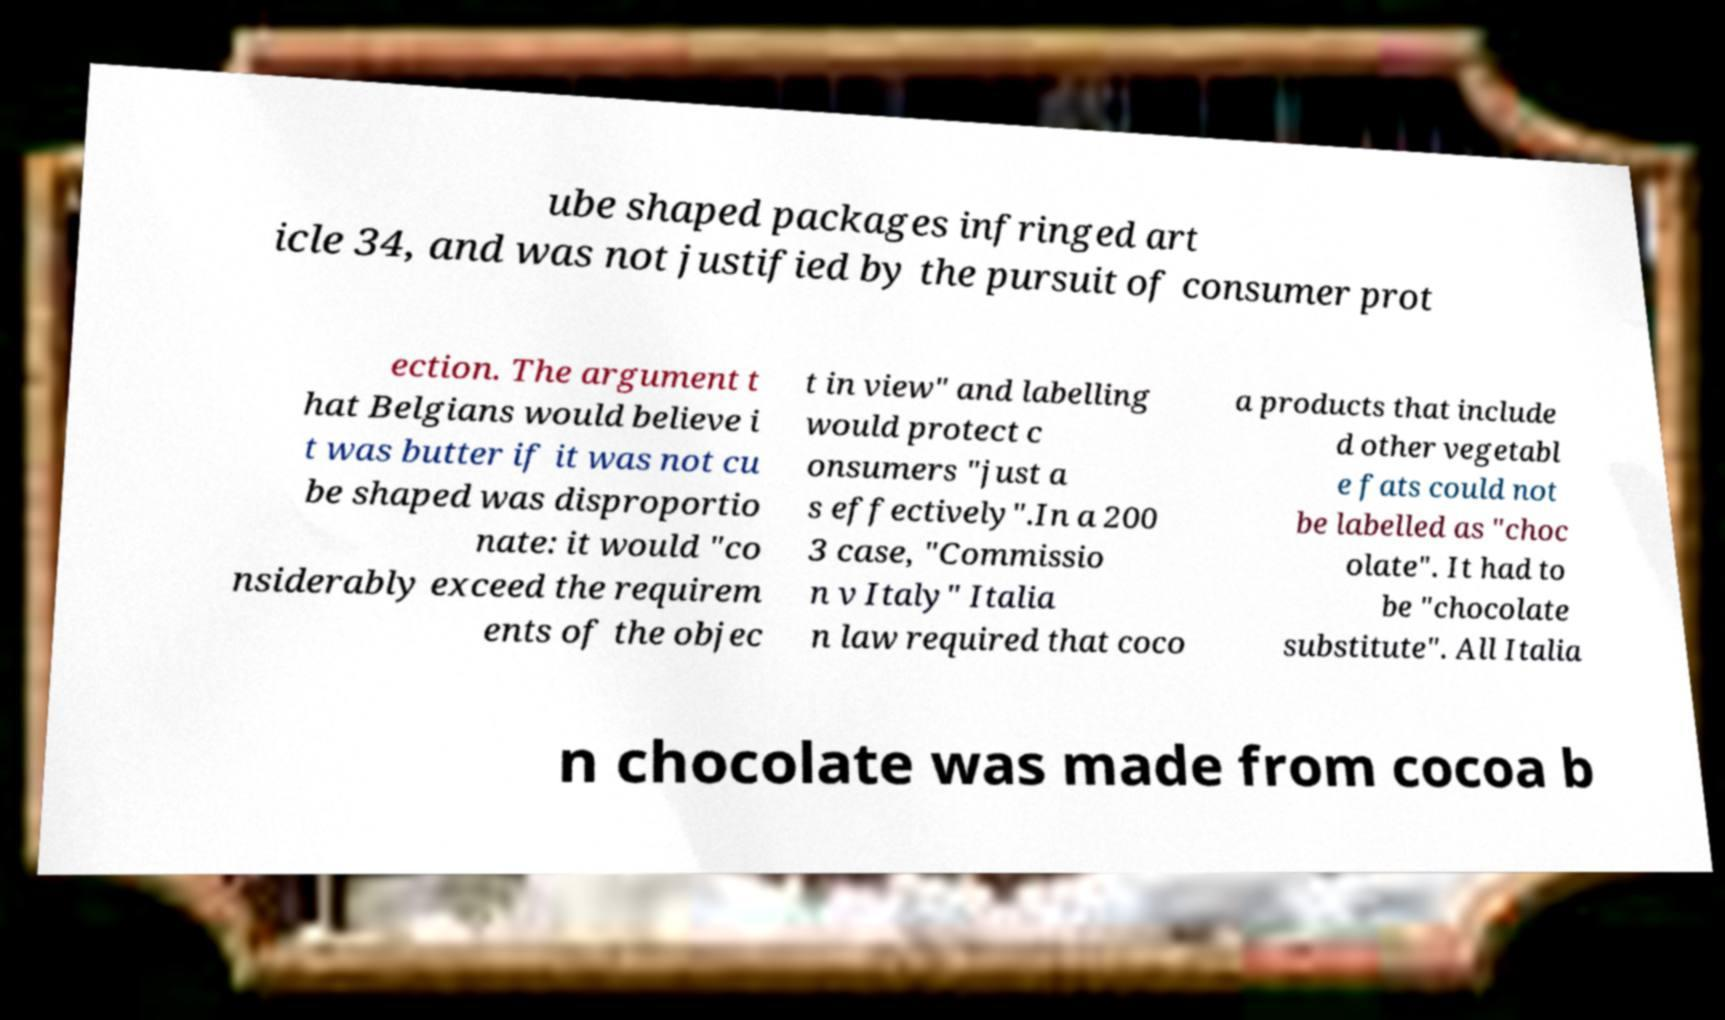Can you read and provide the text displayed in the image?This photo seems to have some interesting text. Can you extract and type it out for me? ube shaped packages infringed art icle 34, and was not justified by the pursuit of consumer prot ection. The argument t hat Belgians would believe i t was butter if it was not cu be shaped was disproportio nate: it would "co nsiderably exceed the requirem ents of the objec t in view" and labelling would protect c onsumers "just a s effectively".In a 200 3 case, "Commissio n v Italy" Italia n law required that coco a products that include d other vegetabl e fats could not be labelled as "choc olate". It had to be "chocolate substitute". All Italia n chocolate was made from cocoa b 